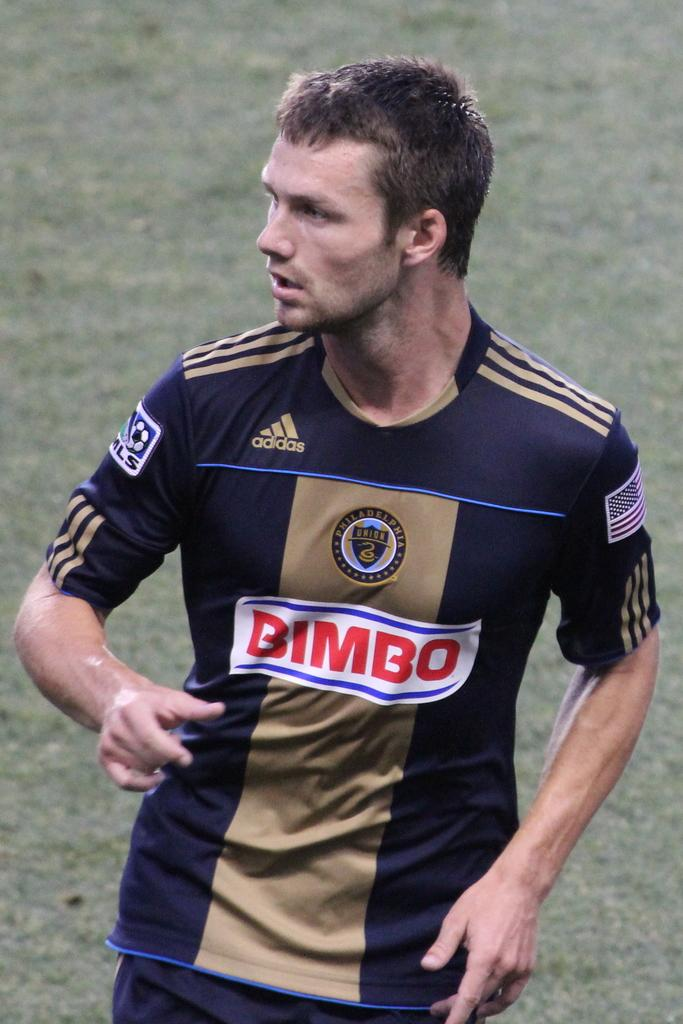<image>
Write a terse but informative summary of the picture. The soccer player has the words "BIMBO" printed across the middle of his jersey. 